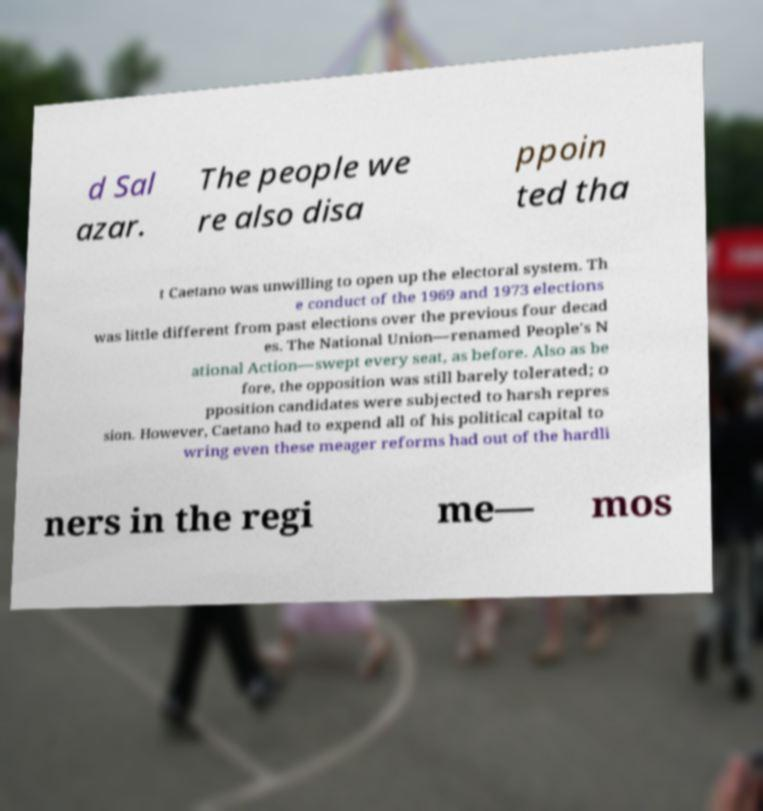I need the written content from this picture converted into text. Can you do that? d Sal azar. The people we re also disa ppoin ted tha t Caetano was unwilling to open up the electoral system. Th e conduct of the 1969 and 1973 elections was little different from past elections over the previous four decad es. The National Union—renamed People's N ational Action—swept every seat, as before. Also as be fore, the opposition was still barely tolerated; o pposition candidates were subjected to harsh repres sion. However, Caetano had to expend all of his political capital to wring even these meager reforms had out of the hardli ners in the regi me— mos 